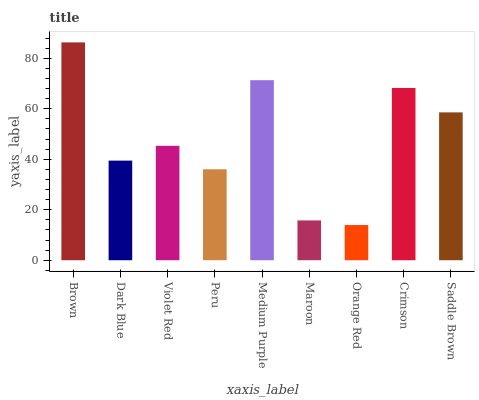Is Orange Red the minimum?
Answer yes or no. Yes. Is Brown the maximum?
Answer yes or no. Yes. Is Dark Blue the minimum?
Answer yes or no. No. Is Dark Blue the maximum?
Answer yes or no. No. Is Brown greater than Dark Blue?
Answer yes or no. Yes. Is Dark Blue less than Brown?
Answer yes or no. Yes. Is Dark Blue greater than Brown?
Answer yes or no. No. Is Brown less than Dark Blue?
Answer yes or no. No. Is Violet Red the high median?
Answer yes or no. Yes. Is Violet Red the low median?
Answer yes or no. Yes. Is Maroon the high median?
Answer yes or no. No. Is Maroon the low median?
Answer yes or no. No. 